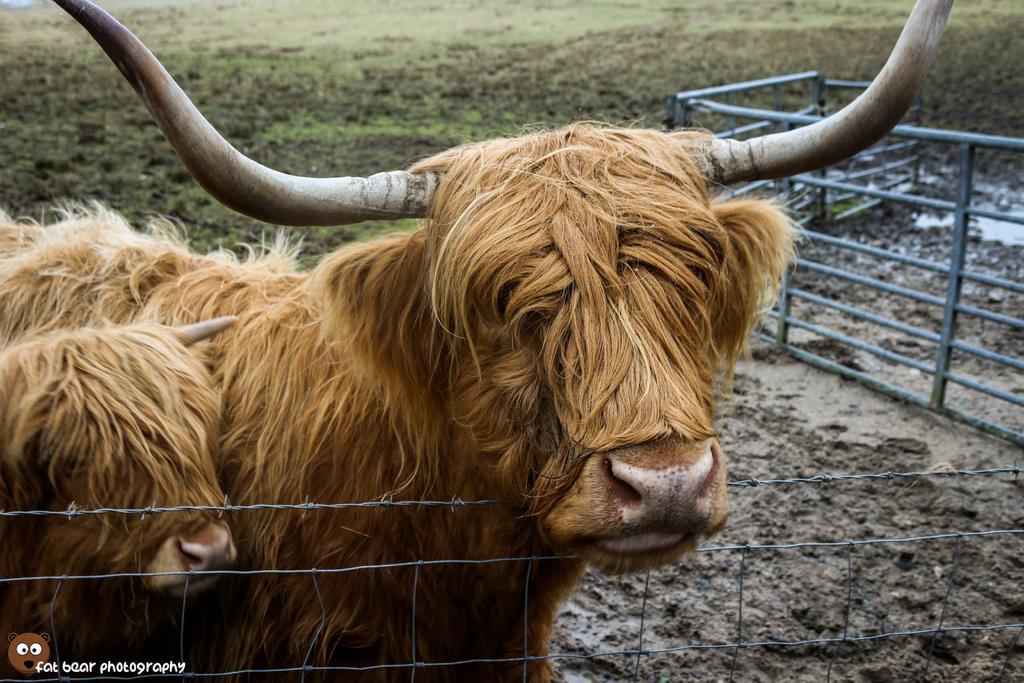Describe this image in one or two sentences. In the foreground of this picture, there are bulls near a fencing. In the background, there is railing, mud and the grass. 